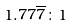Convert formula to latex. <formula><loc_0><loc_0><loc_500><loc_500>1 . 7 7 \overline { 7 } \colon 1</formula> 